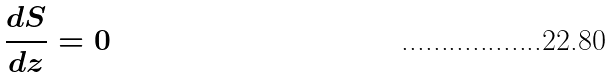<formula> <loc_0><loc_0><loc_500><loc_500>\frac { d S } { d z } = 0</formula> 